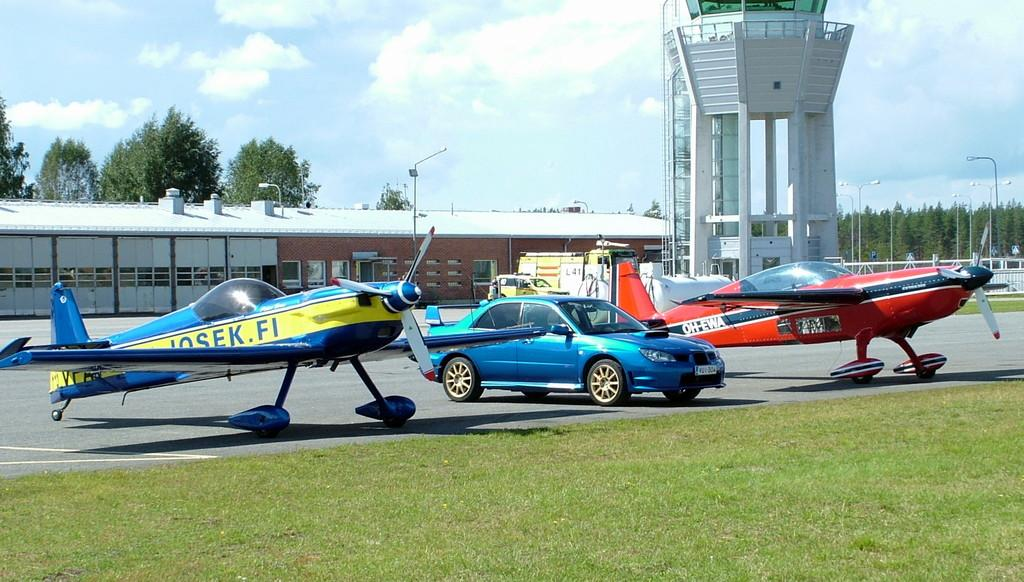What type of vehicles are in the image? There are aircrafts in the image. What other mode of transportation can be seen in the image? There is a car in the image. What structures are present in the image? There are poles, buildings, and trees in the image. What is visible at the top of the image? The sky is visible at the top of the image. What type of vegetation is in the front of the image? There is grass in the front of the image. Can you tell me how many pots are on the notebook in the image? There is no notebook or pot present in the image. What type of fly is buzzing around the aircraft in the image? There is no fly present in the image. 